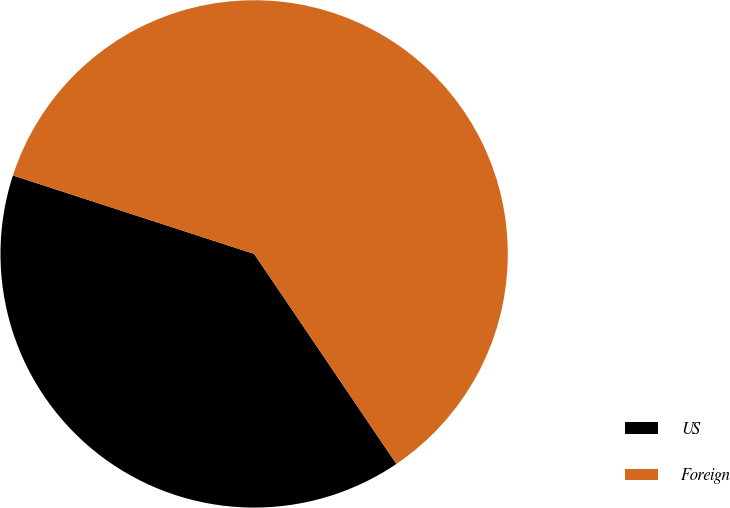<chart> <loc_0><loc_0><loc_500><loc_500><pie_chart><fcel>US<fcel>Foreign<nl><fcel>39.48%<fcel>60.52%<nl></chart> 